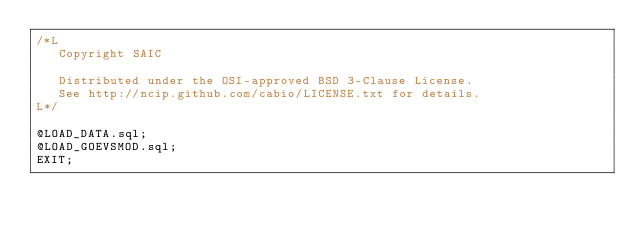Convert code to text. <code><loc_0><loc_0><loc_500><loc_500><_SQL_>/*L
   Copyright SAIC

   Distributed under the OSI-approved BSD 3-Clause License.
   See http://ncip.github.com/cabio/LICENSE.txt for details.
L*/

@LOAD_DATA.sql;
@LOAD_GOEVSMOD.sql;
EXIT;
</code> 